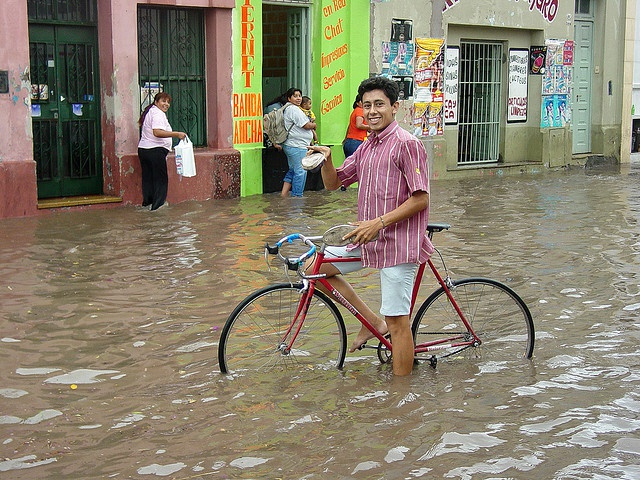Describe the objects in this image and their specific colors. I can see bicycle in lightpink, tan, darkgray, gray, and black tones, people in lightpink, brown, darkgray, violet, and lightgray tones, people in lightpink, black, lavender, darkgray, and brown tones, people in lightpink, lightgray, darkgray, gray, and black tones, and people in lightpink, red, brown, and navy tones in this image. 